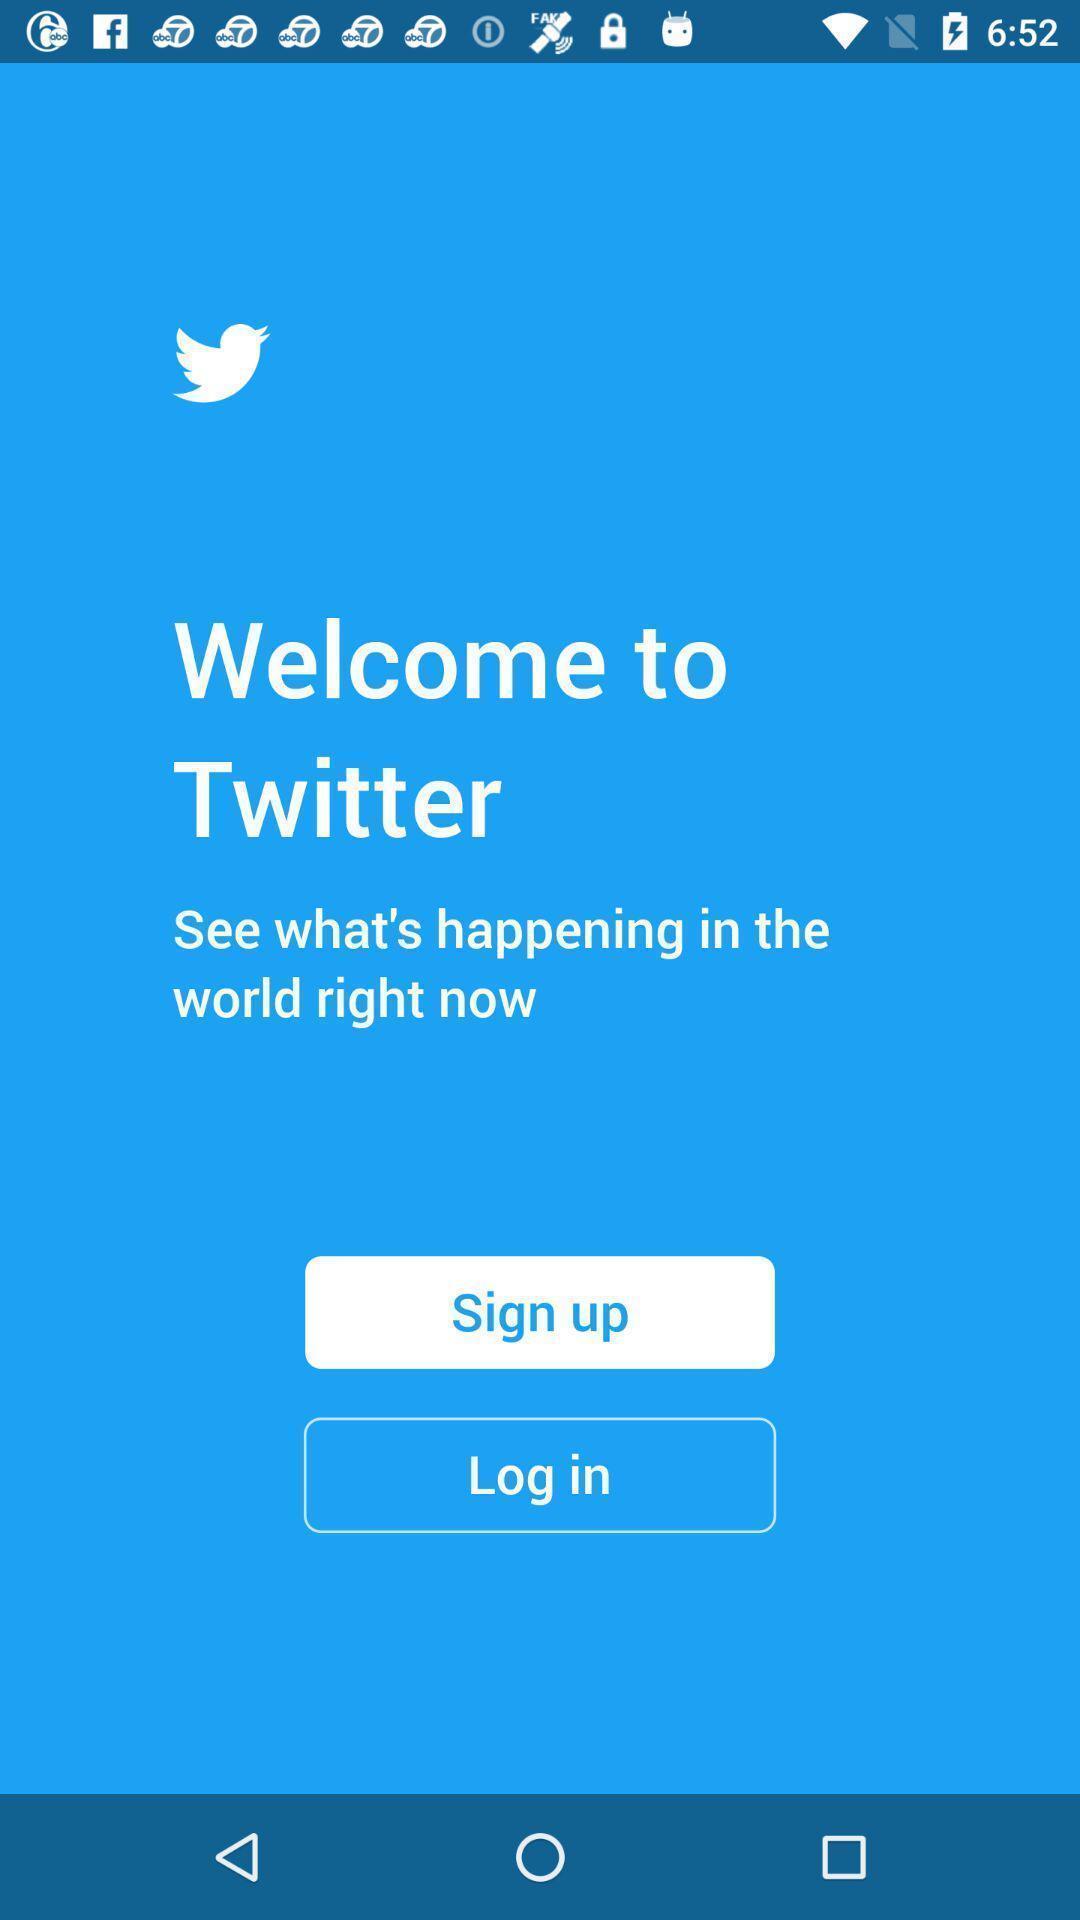Give me a summary of this screen capture. Welcome page for social application with sign-up and log-in options. 